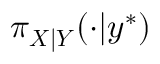<formula> <loc_0><loc_0><loc_500><loc_500>\pi _ { X | Y } ( \cdot | y ^ { * } )</formula> 